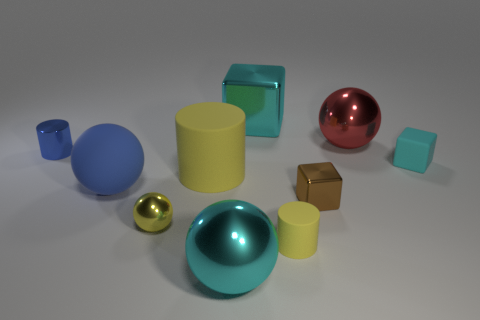Do the cyan block that is right of the tiny brown metal block and the cyan object that is in front of the brown block have the same material?
Provide a short and direct response. No. There is a small metal object that is left of the big object that is to the left of the yellow sphere; what number of small cylinders are to the left of it?
Provide a succinct answer. 0. What material is the blue object that is the same shape as the small yellow metal thing?
Offer a terse response. Rubber. What is the color of the big metallic sphere in front of the rubber cube?
Your answer should be very brief. Cyan. Do the cyan ball and the yellow cylinder that is on the right side of the big metal block have the same material?
Give a very brief answer. No. There is a tiny yellow object that is made of the same material as the tiny cyan object; what is its shape?
Provide a succinct answer. Cylinder. Is the size of the metallic block behind the blue sphere the same as the cyan metallic thing in front of the large red object?
Give a very brief answer. Yes. The cyan cube on the right side of the cyan cube that is behind the shiny object on the left side of the blue rubber thing is made of what material?
Your answer should be compact. Rubber. Do the brown shiny block and the rubber cylinder that is right of the cyan metal cube have the same size?
Provide a succinct answer. Yes. There is a metal thing that is both to the left of the large matte cylinder and to the right of the small blue shiny cylinder; what is its size?
Make the answer very short. Small. 